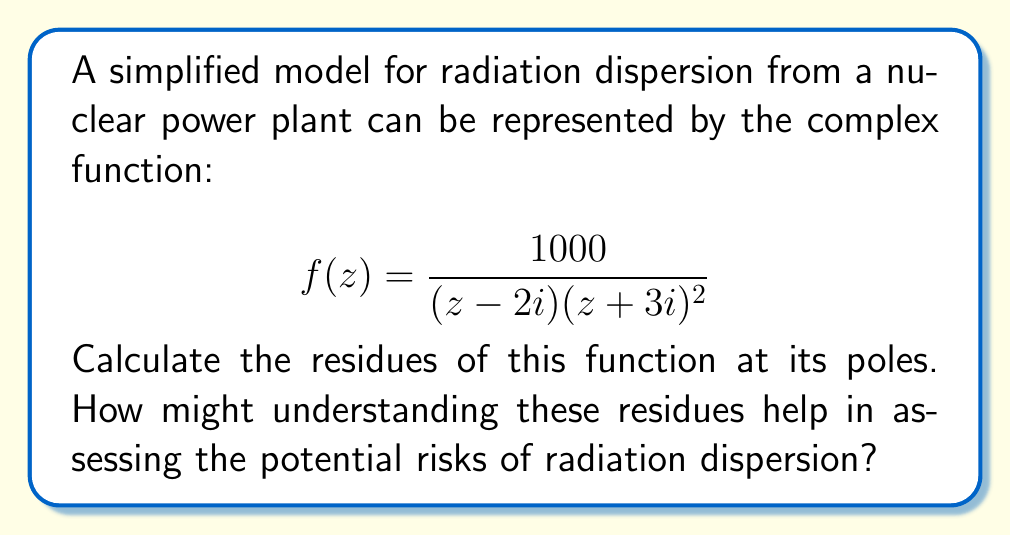Can you answer this question? To calculate the residues of the given function, we need to identify its poles and determine their order. The function has two poles:

1. $z_1 = 2i$ (simple pole)
2. $z_2 = -3i$ (double pole)

For the simple pole at $z_1 = 2i$:
The residue can be calculated using the formula:
$$\text{Res}(f, 2i) = \lim_{z \to 2i} (z-2i)f(z)$$

$$\begin{aligned}
\text{Res}(f, 2i) &= \lim_{z \to 2i} \frac{1000(z-2i)}{(z-2i)(z+3i)^2} \\
&= \lim_{z \to 2i} \frac{1000}{(z+3i)^2} \\
&= \frac{1000}{(2i+3i)^2} \\
&= \frac{1000}{25i^2} \\
&= -40
\end{aligned}$$

For the double pole at $z_2 = -3i$:
The residue for a double pole is calculated using the formula:
$$\text{Res}(f, -3i) = \lim_{z \to -3i} \frac{d}{dz}[(z+3i)^2f(z)]$$

$$\begin{aligned}
\text{Res}(f, -3i) &= \lim_{z \to -3i} \frac{d}{dz}\left[\frac{1000}{z-2i}\right] \\
&= \lim_{z \to -3i} \frac{-1000}{(z-2i)^2} \\
&= \frac{-1000}{(-3i-2i)^2} \\
&= \frac{-1000}{(-5i)^2} \\
&= \frac{-1000}{-25} \\
&= 40
\end{aligned}$$

Understanding these residues can help assess potential risks of radiation dispersion by:

1. Providing information about the strength and behavior of the radiation source at different locations.
2. Helping to model the rate of change of radiation concentration in different areas.
3. Allowing for the calculation of contour integrals around the power plant, which can represent total radiation flux in certain regions.
Answer: The residues of the given function are:
$$\text{Res}(f, 2i) = -40$$
$$\text{Res}(f, -3i) = 40$$ 